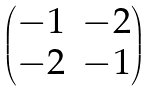<formula> <loc_0><loc_0><loc_500><loc_500>\begin{pmatrix} - 1 & - 2 \\ - 2 & - 1 \end{pmatrix}</formula> 